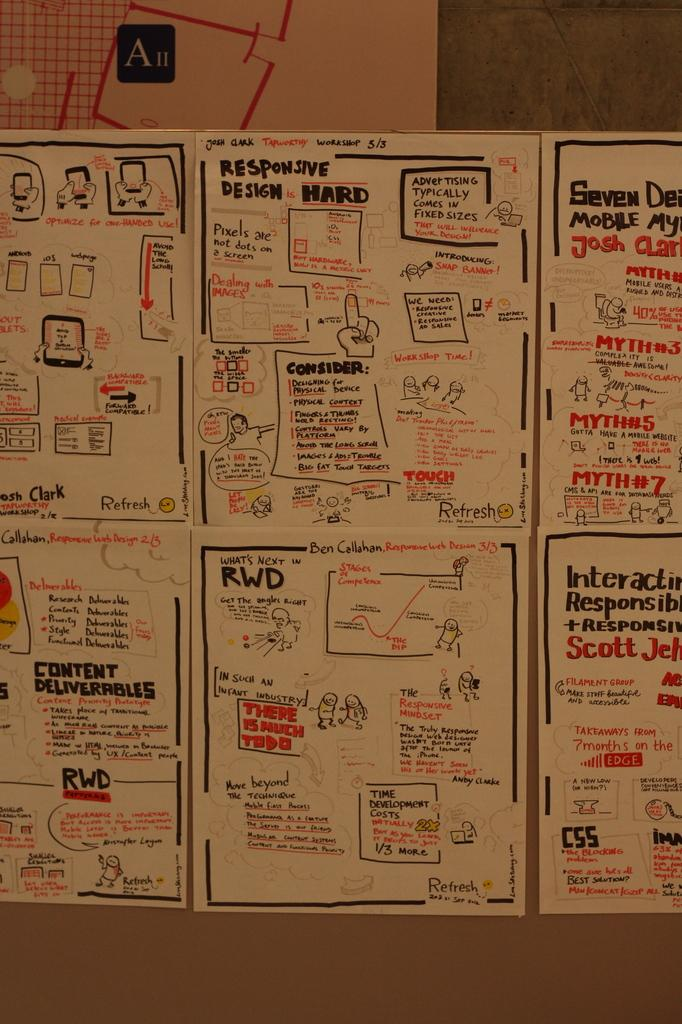<image>
Relay a brief, clear account of the picture shown. A serious of well illustrated papers, the upper middle of which is about responsive design. 